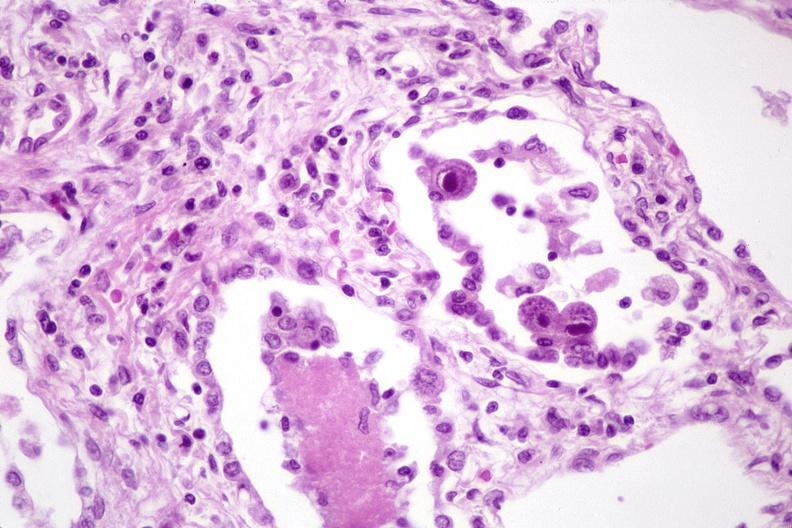s lymphangiomatosis generalized present?
Answer the question using a single word or phrase. No 